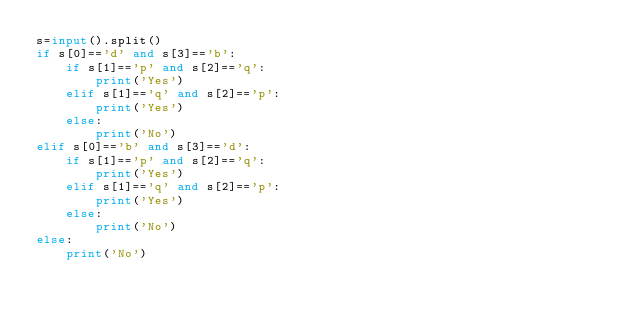<code> <loc_0><loc_0><loc_500><loc_500><_Python_>s=input().split()
if s[0]=='d' and s[3]=='b':
    if s[1]=='p' and s[2]=='q':
        print('Yes')
    elif s[1]=='q' and s[2]=='p':
        print('Yes')
    else:
        print('No')
elif s[0]=='b' and s[3]=='d':
    if s[1]=='p' and s[2]=='q':
        print('Yes')
    elif s[1]=='q' and s[2]=='p':
        print('Yes')
    else:
        print('No')
else:
    print('No')</code> 